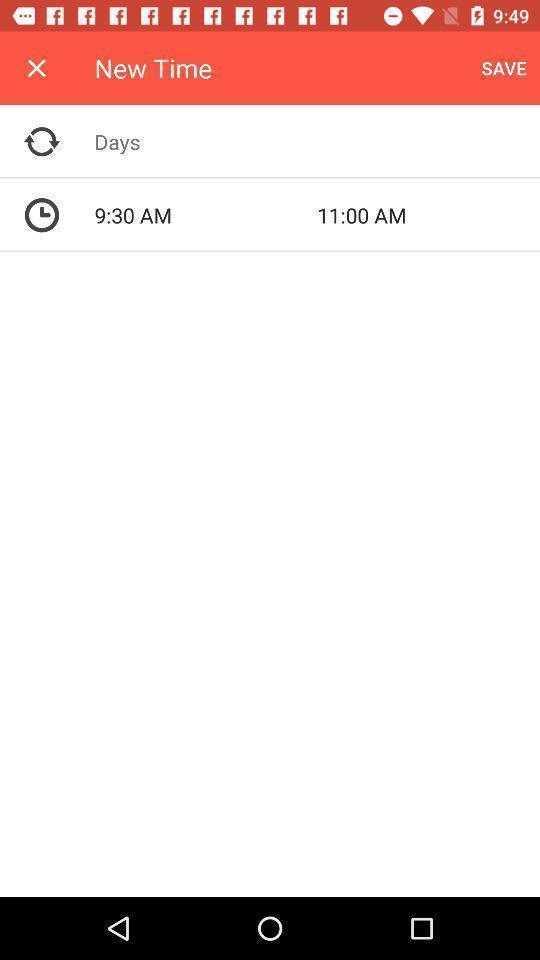Describe the content in this image. Screen showing new time. 